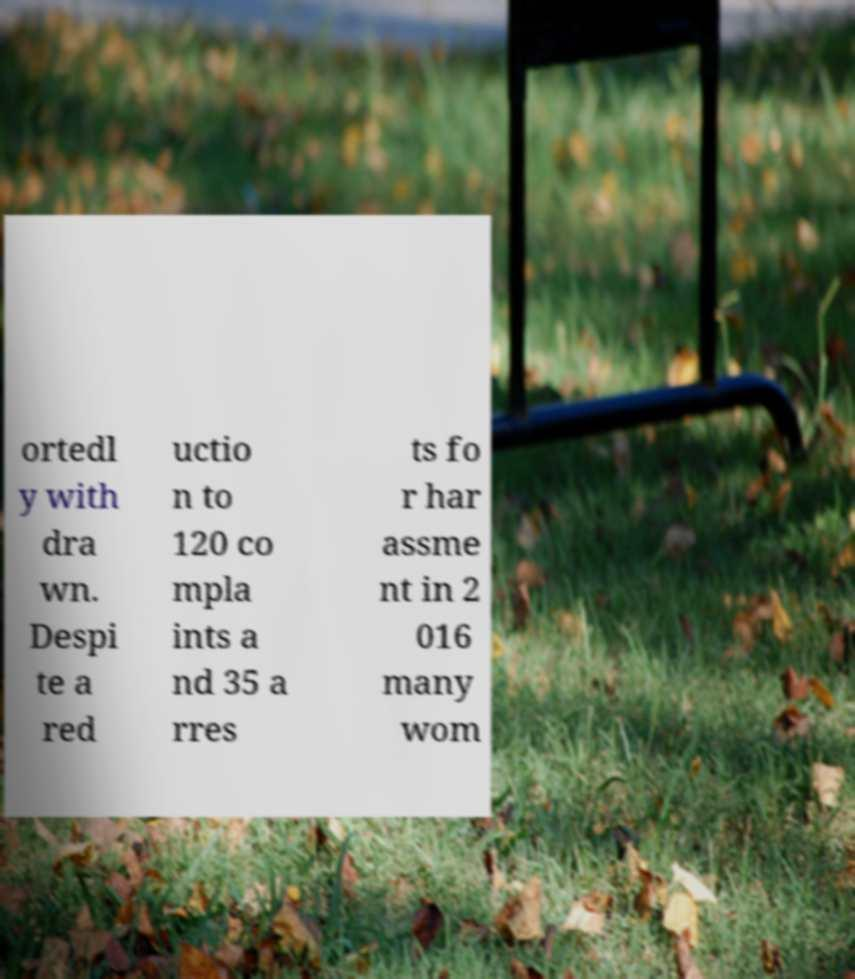Could you extract and type out the text from this image? ortedl y with dra wn. Despi te a red uctio n to 120 co mpla ints a nd 35 a rres ts fo r har assme nt in 2 016 many wom 